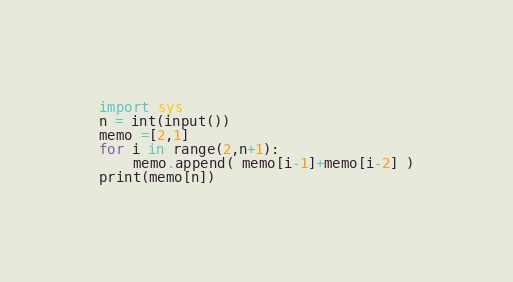Convert code to text. <code><loc_0><loc_0><loc_500><loc_500><_Python_>import sys
n = int(input())
memo =[2,1]
for i in range(2,n+1):
    memo.append( memo[i-1]+memo[i-2] )
print(memo[n])
</code> 